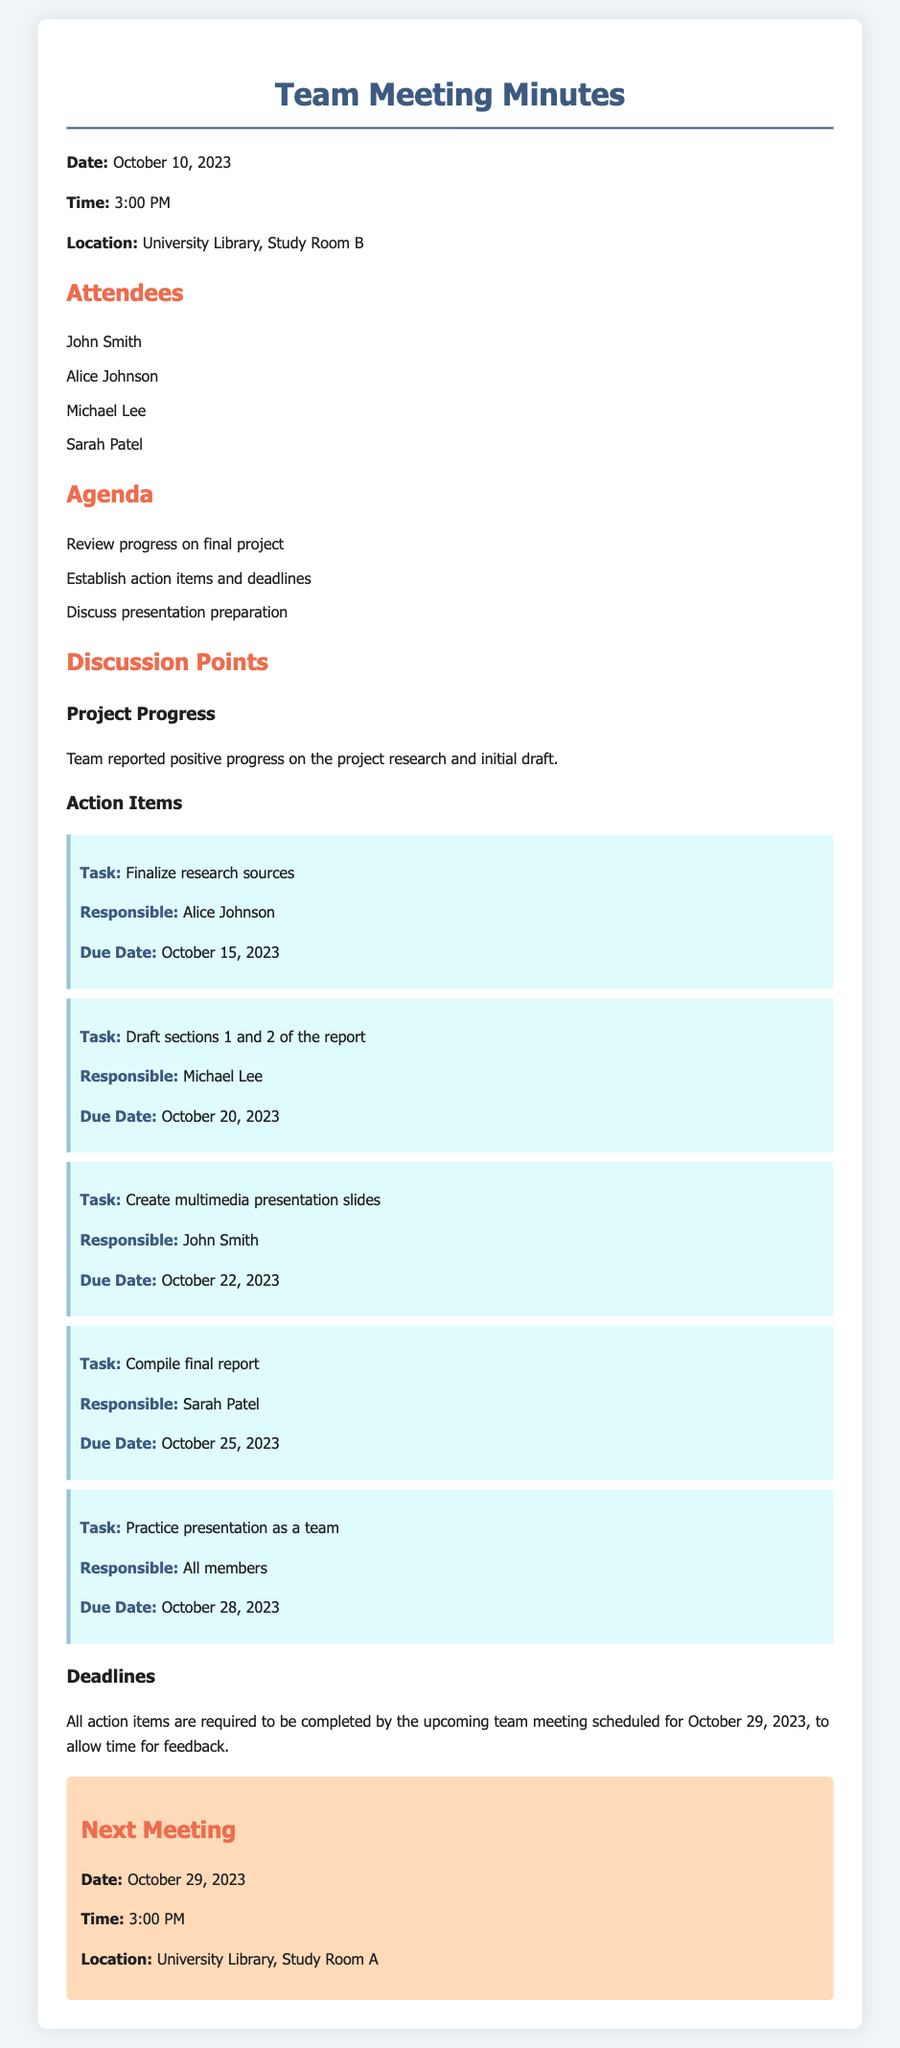What is the date of the meeting? The date of the meeting is explicitly stated in the document as October 10, 2023.
Answer: October 10, 2023 Who is responsible for finalizing research sources? The document specifies Alice Johnson as the person responsible for finalizing research sources.
Answer: Alice Johnson What is the due date for creating multimedia presentation slides? The document lists the due date for creating multimedia presentation slides as October 22, 2023.
Answer: October 22, 2023 How many sections of the report is Michael Lee tasked with drafting? Michael Lee is assigned to draft sections 1 and 2 of the report, indicating two sections.
Answer: 2 What is the latest due date mentioned for actions to be completed? The document indicates that all action items should be completed by October 29, 2023, which is the date of the next meeting.
Answer: October 29, 2023 Who is responsible for compiling the final report? According to the document, Sarah Patel is responsible for compiling the final report.
Answer: Sarah Patel What is the location of the next team meeting? The location for the next team meeting is detailed in the document as University Library, Study Room A.
Answer: University Library, Study Room A What is the action item assigned to all members? The document specifies that all members are tasked with practicing the presentation as a team.
Answer: Practice presentation as a team What color is used to distinguish action items in the document? The action items are highlighted with a background color described as light blue in the document.
Answer: Light blue 